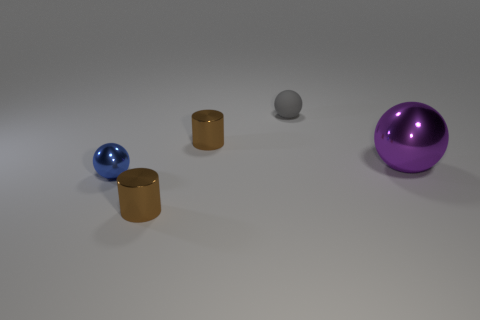Subtract all cyan balls. Subtract all brown blocks. How many balls are left? 3 Add 5 tiny balls. How many objects exist? 10 Subtract all cylinders. How many objects are left? 3 Subtract 0 cyan spheres. How many objects are left? 5 Subtract all tiny metallic objects. Subtract all big red rubber spheres. How many objects are left? 2 Add 5 spheres. How many spheres are left? 8 Add 2 purple metallic things. How many purple metallic things exist? 3 